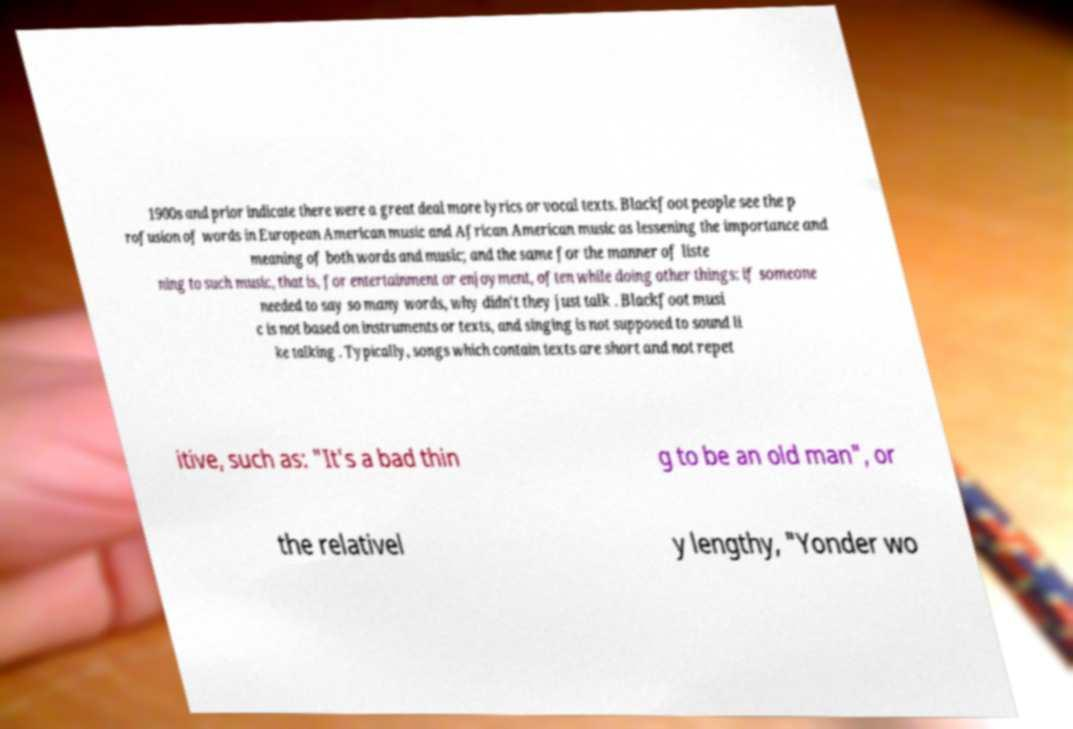For documentation purposes, I need the text within this image transcribed. Could you provide that? 1900s and prior indicate there were a great deal more lyrics or vocal texts. Blackfoot people see the p rofusion of words in European American music and African American music as lessening the importance and meaning of both words and music; and the same for the manner of liste ning to such music, that is, for entertainment or enjoyment, often while doing other things: if someone needed to say so many words, why didn't they just talk . Blackfoot musi c is not based on instruments or texts, and singing is not supposed to sound li ke talking . Typically, songs which contain texts are short and not repet itive, such as: "It's a bad thin g to be an old man", or the relativel y lengthy, "Yonder wo 